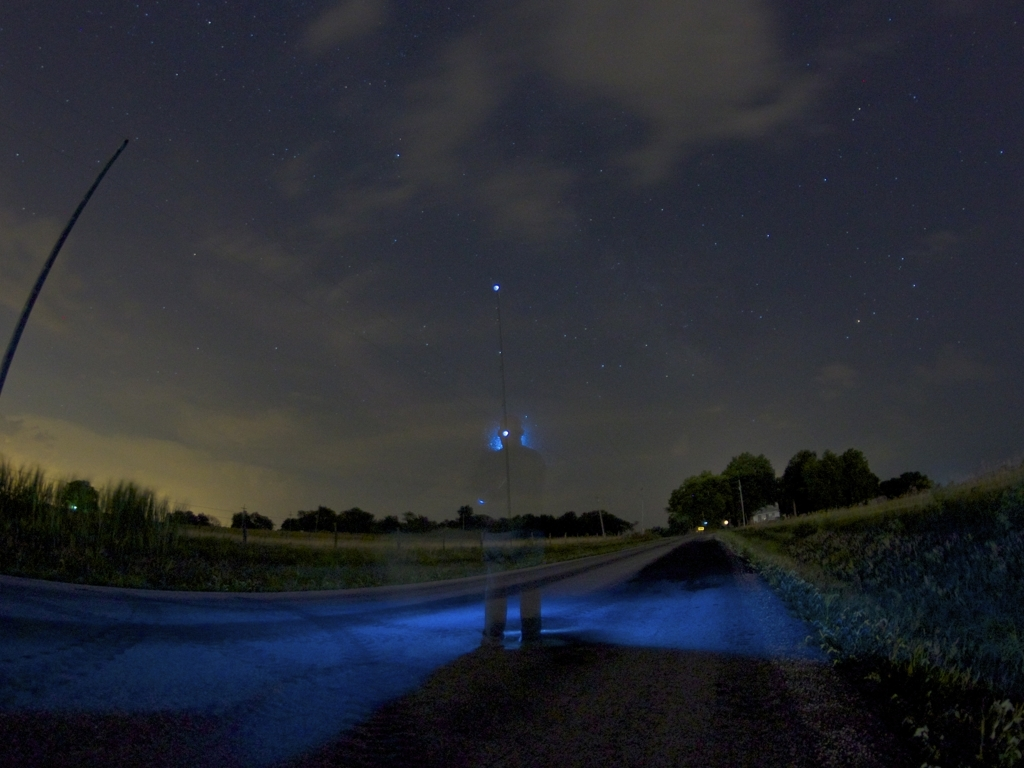Can you describe the technique used to create the ghostly effect in the image? The ghostly effect is likely the result of a long-exposure shot. The camera's shutter remains open for an extended period, capturing the stationary background crisply while blurring any moving elements, in this case, creating a transparent effect as the person moved during the exposure. Why do you think the person chose to take the photo this way? This technique is often used by photographers to convey a sense of motion or passage of time. It can also add a surreal or artistic quality to the photo, highlighting the contrast between the ephemeral nature of human presence and the permanence of the surroundings. 